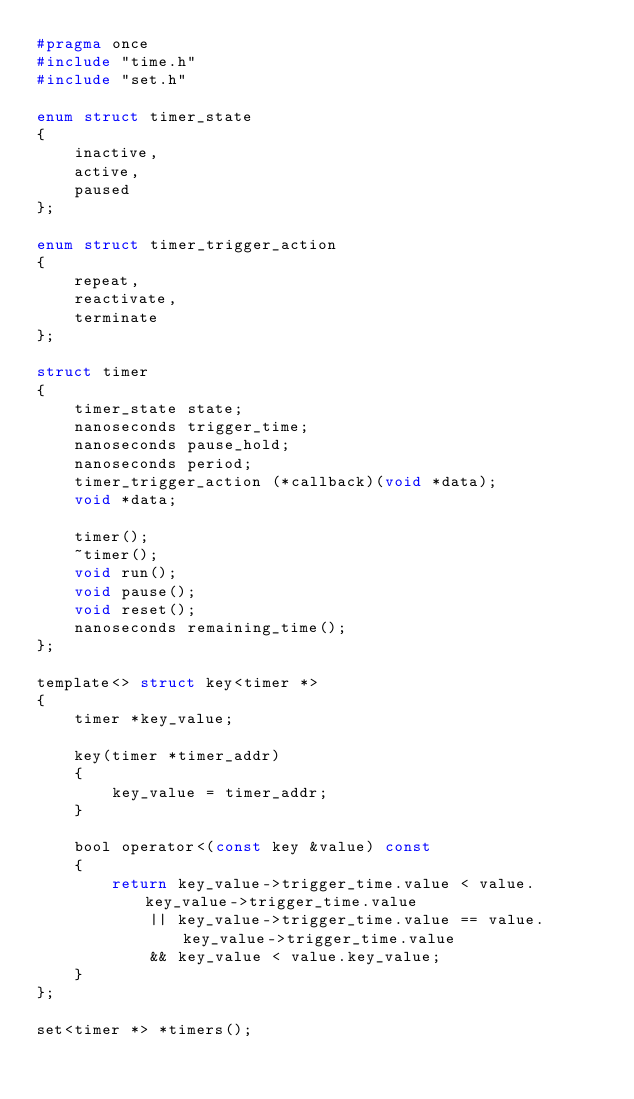<code> <loc_0><loc_0><loc_500><loc_500><_C_>#pragma once
#include "time.h"
#include "set.h"

enum struct timer_state
{
	inactive,
	active,
	paused
};

enum struct timer_trigger_action
{
	repeat,
	reactivate,
	terminate
};

struct timer
{
	timer_state state;
	nanoseconds trigger_time;
	nanoseconds pause_hold;
	nanoseconds period;
	timer_trigger_action (*callback)(void *data);
	void *data;

	timer();
	~timer();
	void run();
	void pause();
	void reset();
	nanoseconds remaining_time();
};

template<> struct key<timer *>
{
	timer *key_value;

	key(timer *timer_addr)
	{
		key_value = timer_addr;
	}

	bool operator<(const key &value) const
	{
		return key_value->trigger_time.value < value.key_value->trigger_time.value
			|| key_value->trigger_time.value == value.key_value->trigger_time.value
			&& key_value < value.key_value;
	}
};

set<timer *> *timers();
</code> 